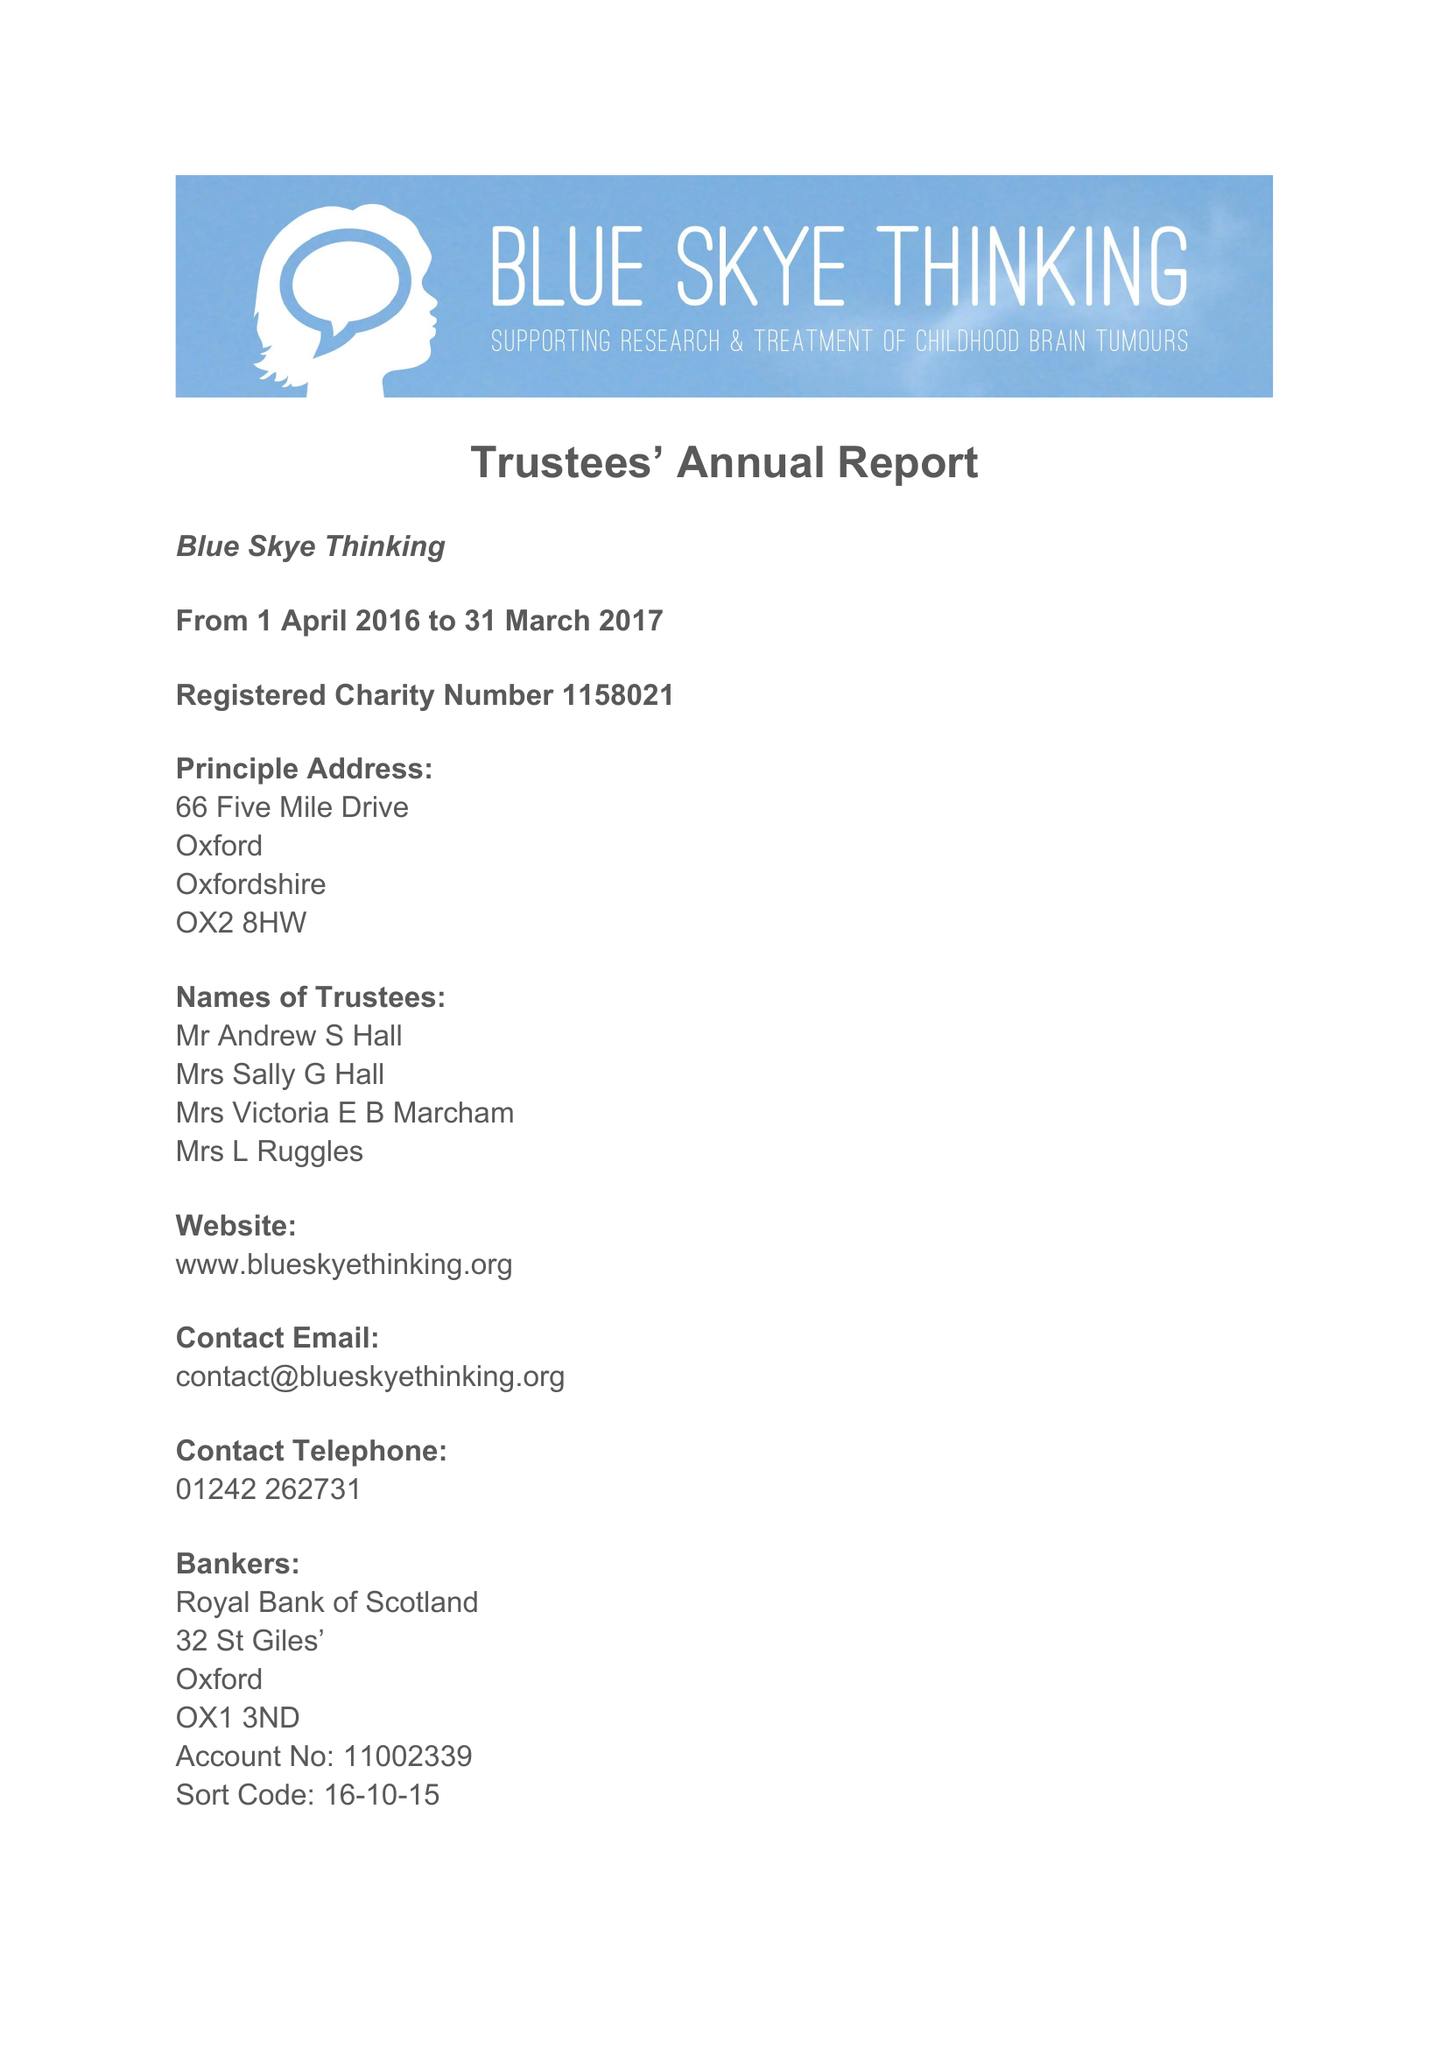What is the value for the charity_name?
Answer the question using a single word or phrase. Blue Skye Thinking 